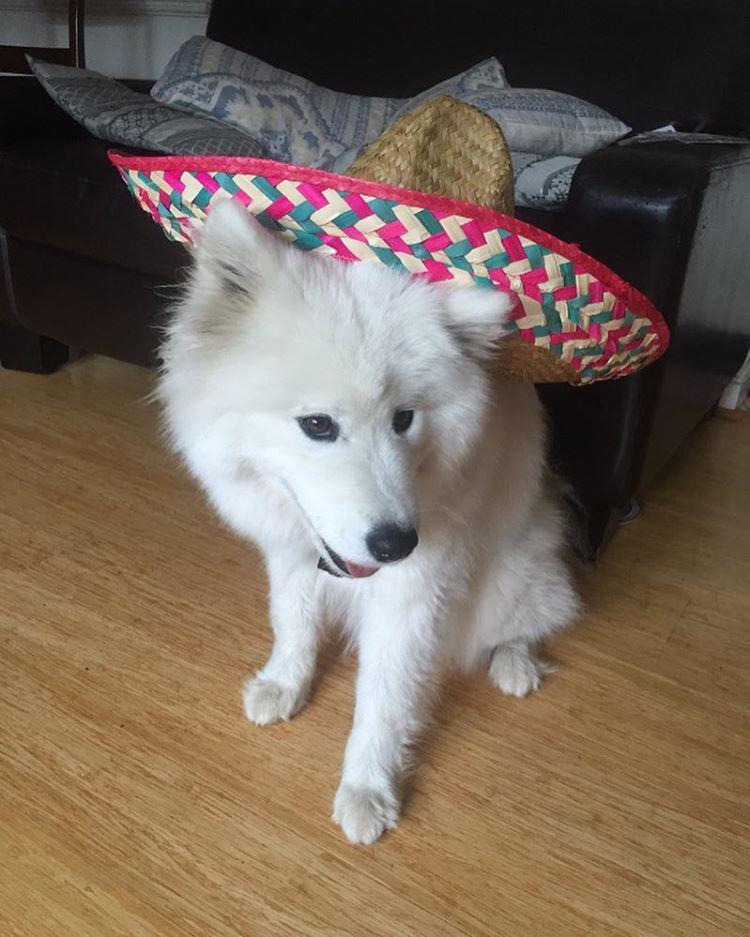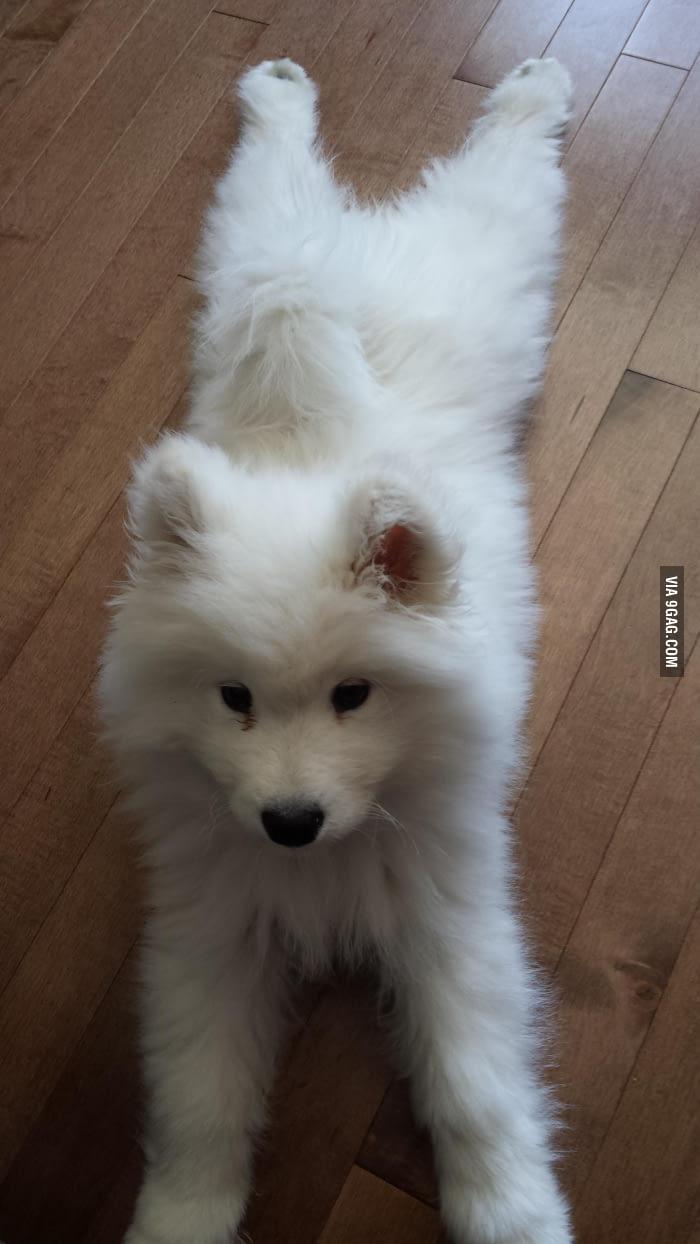The first image is the image on the left, the second image is the image on the right. Considering the images on both sides, is "An image shows one white dog wearing something other than a dog collar." valid? Answer yes or no. Yes. The first image is the image on the left, the second image is the image on the right. Analyze the images presented: Is the assertion "One dog is outdoors, and one dog is indoors." valid? Answer yes or no. No. 